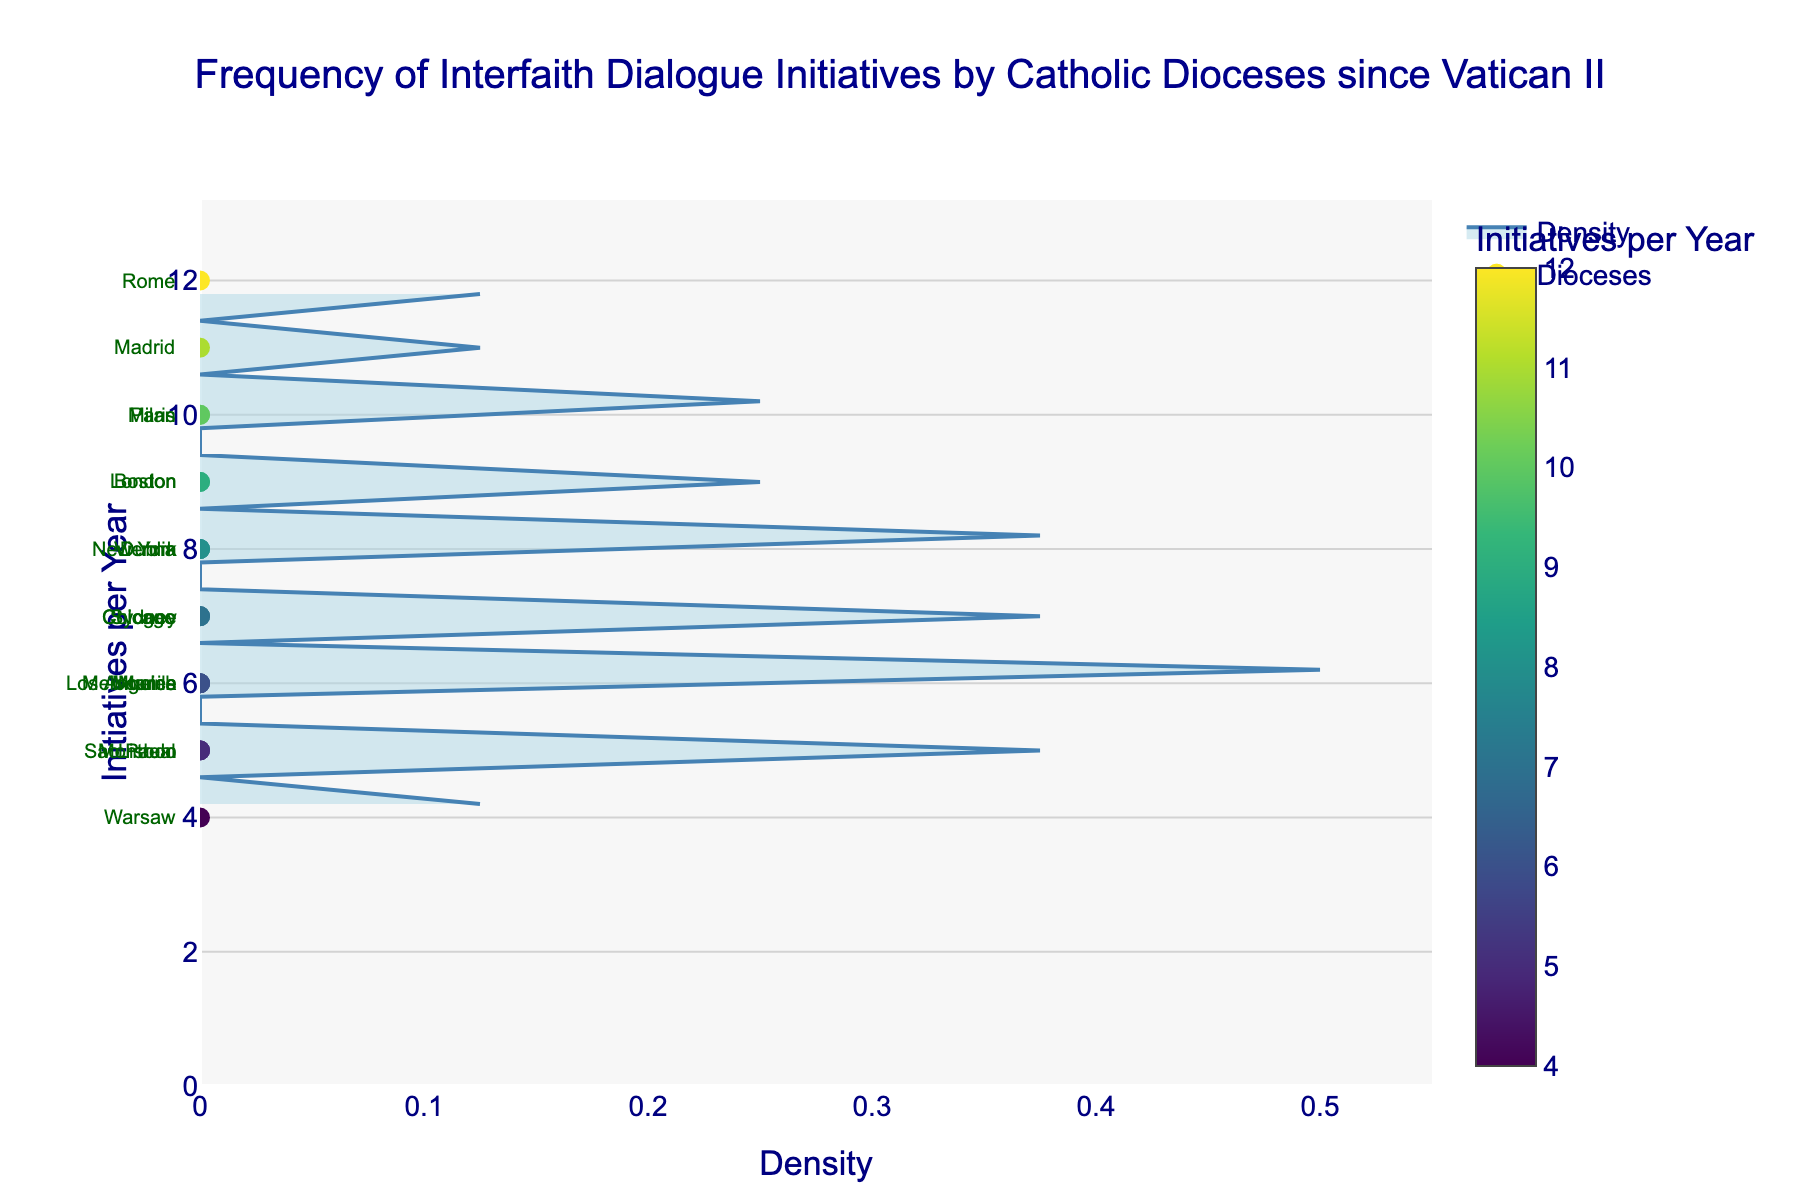What is the title of the figure? The title is prominently displayed at the top-middle of the figure in a bold, large font. It reads: "Frequency of Interfaith Dialogue Initiatives by Catholic Dioceses since Vatican II."
Answer: "Frequency of Interfaith Dialogue Initiatives by Catholic Dioceses since Vatican II" How many dioceses conducted at least 8 initiatives per year? To find this, count the number of data points (markers) on the y-axis at or above the value of 8. These dioceses are Rome, New York, Paris, London, Madrid, Dublin, Vienna, and Milan—8 dioceses in total
Answer: 8 From the scatter points, which diocese has the lowest frequency of initiatives per year? By looking at the lowest point on the y-axis where a scatter point is marked, the diocese labeled at 4 initiatives per year is Warsaw.
Answer: Warsaw What is the maximum number of interfaith initiatives conducted by any diocese? The highest point on the y-axis gives this value. Looking at the scatter points, the highest marker is at 12 initiatives per year, which corresponds to Rome.
Answer: 12 Calculate the average number of interfaith initiatives per year across all dioceses shown in the figure. Add the number of initiatives (12, 8, 10, 6, 9, 7, 5, 11, 7, 6, 8, 5, 4, 9, 6, 5, 7, 8, 10, 6) and divide by the total number of dioceses (20). Sum = 143; 143/20 = 7.15
Answer: 7.15 Compare Paris and Chicago. Which diocese conducts more initiatives per year? Look at the y-axis positions of their markers: Paris is at 10 and Chicago at 7. Therefore, Paris conducts more initiatives per year than Chicago.
Answer: Paris Does the density of initiatives per year have a peak, and where is it located? The density plot (filled with light blue) shows a peak at the y-axis value where it is most concentrated. Here, it peaks around 7 initiatives per year.
Answer: 7 initiatives per year Which dioceses conduct exactly 7 initiatives per year? Locate the scatter points at the y-axis value of 7. The labeled dioceses are Cologne, Chicago, Sydney, and Los Angeles.
Answer: Cologne, Chicago, Sydney, Los Angeles Considering only dioceses with fewer than 6 initiatives per year, how many dioceses fall into this category? Count the scatter points on the y-axis that are below the mark of 6 initiatives per year. These are Sao Paulo, Montreal, Warsaw, and Lisbon. Total count = 4
Answer: 4 